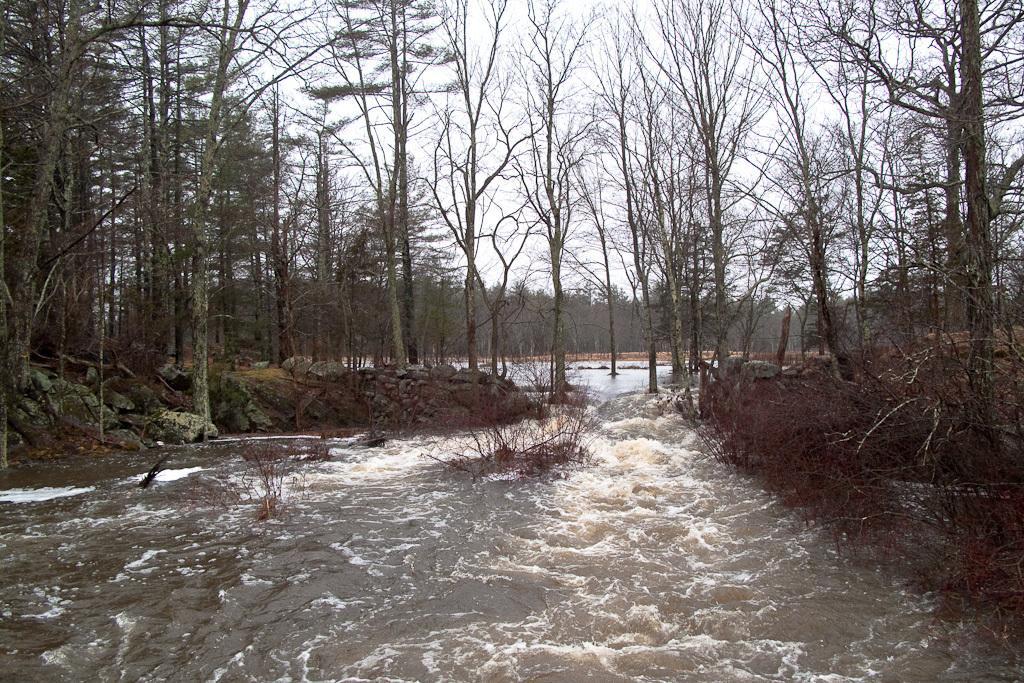Describe this image in one or two sentences. In this image we can see some trees, plants, grass, rocks, also we can see the river, and the sky. 